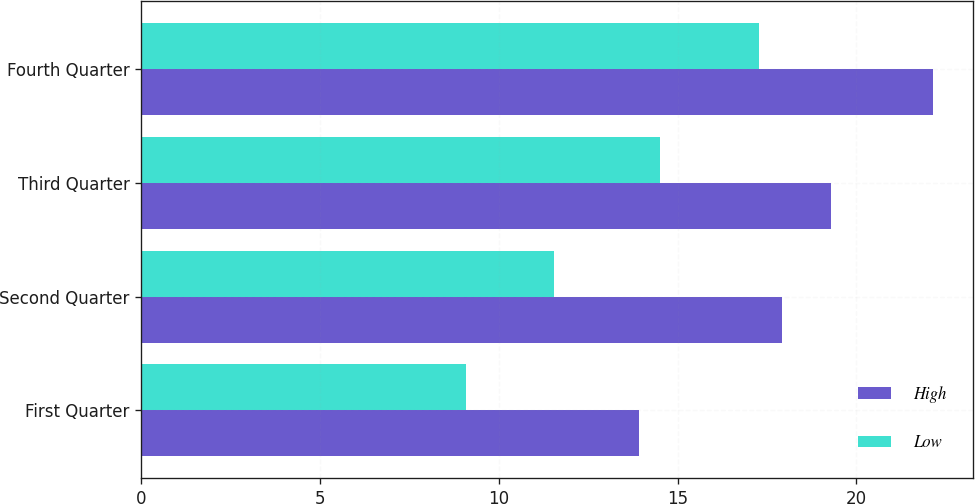Convert chart to OTSL. <chart><loc_0><loc_0><loc_500><loc_500><stacked_bar_chart><ecel><fcel>First Quarter<fcel>Second Quarter<fcel>Third Quarter<fcel>Fourth Quarter<nl><fcel>High<fcel>13.91<fcel>17.92<fcel>19.3<fcel>22.15<nl><fcel>Low<fcel>9.07<fcel>11.54<fcel>14.5<fcel>17.28<nl></chart> 